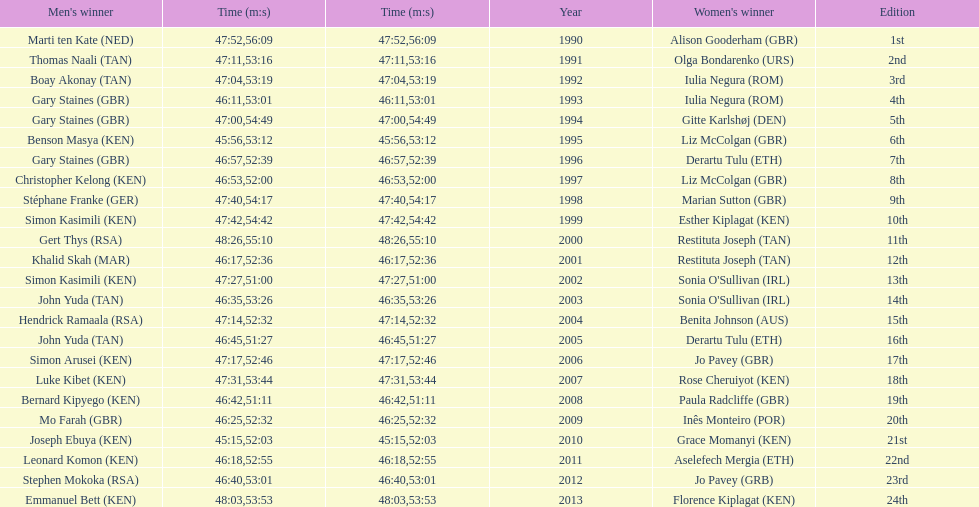Where any women faster than any men? No. 